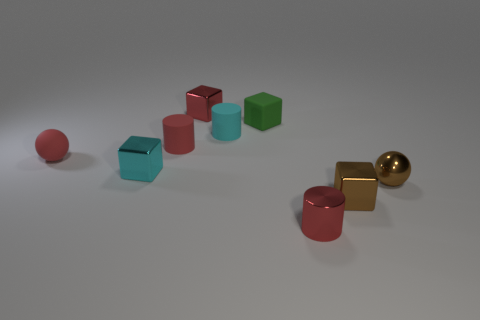Subtract all tiny brown shiny cubes. How many cubes are left? 3 Add 1 tiny blocks. How many objects exist? 10 Add 4 gray matte cubes. How many gray matte cubes exist? 4 Subtract all brown blocks. How many blocks are left? 3 Subtract 0 purple blocks. How many objects are left? 9 Subtract all balls. How many objects are left? 7 Subtract 1 spheres. How many spheres are left? 1 Subtract all green spheres. Subtract all green cylinders. How many spheres are left? 2 Subtract all red spheres. How many cyan cylinders are left? 1 Subtract all tiny blocks. Subtract all small matte objects. How many objects are left? 1 